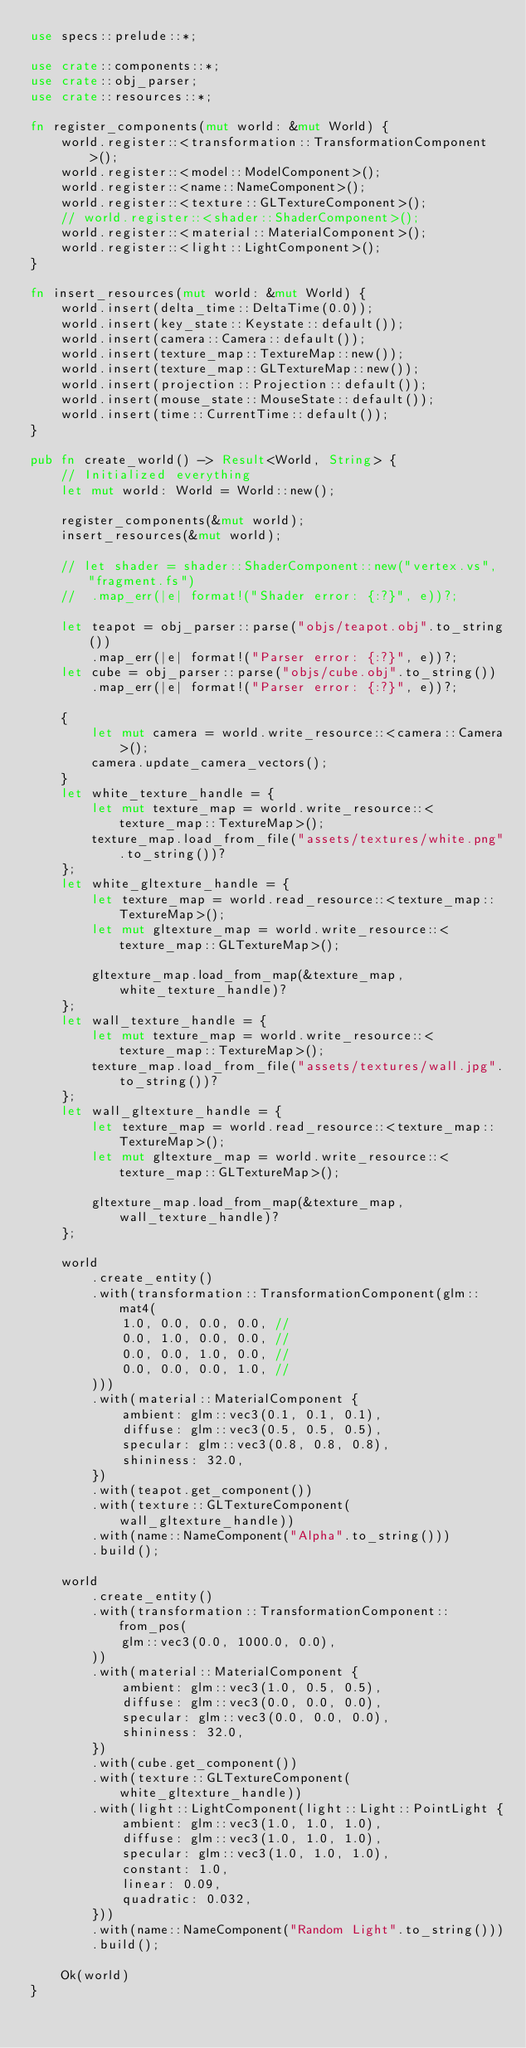<code> <loc_0><loc_0><loc_500><loc_500><_Rust_>use specs::prelude::*;

use crate::components::*;
use crate::obj_parser;
use crate::resources::*;

fn register_components(mut world: &mut World) {
	world.register::<transformation::TransformationComponent>();
	world.register::<model::ModelComponent>();
	world.register::<name::NameComponent>();
	world.register::<texture::GLTextureComponent>();
	// world.register::<shader::ShaderComponent>();
	world.register::<material::MaterialComponent>();
	world.register::<light::LightComponent>();
}

fn insert_resources(mut world: &mut World) {
	world.insert(delta_time::DeltaTime(0.0));
	world.insert(key_state::Keystate::default());
	world.insert(camera::Camera::default());
	world.insert(texture_map::TextureMap::new());
	world.insert(texture_map::GLTextureMap::new());
	world.insert(projection::Projection::default());
	world.insert(mouse_state::MouseState::default());
	world.insert(time::CurrentTime::default());
}

pub fn create_world() -> Result<World, String> {
	// Initialized everything
	let mut world: World = World::new();

	register_components(&mut world);
	insert_resources(&mut world);

	// let shader = shader::ShaderComponent::new("vertex.vs", "fragment.fs")
	// 	.map_err(|e| format!("Shader error: {:?}", e))?;

	let teapot = obj_parser::parse("objs/teapot.obj".to_string())
		.map_err(|e| format!("Parser error: {:?}", e))?;
	let cube = obj_parser::parse("objs/cube.obj".to_string())
		.map_err(|e| format!("Parser error: {:?}", e))?;

	{
		let mut camera = world.write_resource::<camera::Camera>();
		camera.update_camera_vectors();
	}
	let white_texture_handle = {
		let mut texture_map = world.write_resource::<texture_map::TextureMap>();
		texture_map.load_from_file("assets/textures/white.png".to_string())?
	};
	let white_gltexture_handle = {
		let texture_map = world.read_resource::<texture_map::TextureMap>();
		let mut gltexture_map = world.write_resource::<texture_map::GLTextureMap>();

		gltexture_map.load_from_map(&texture_map, white_texture_handle)?
	};
	let wall_texture_handle = {
		let mut texture_map = world.write_resource::<texture_map::TextureMap>();
		texture_map.load_from_file("assets/textures/wall.jpg".to_string())?
	};
	let wall_gltexture_handle = {
		let texture_map = world.read_resource::<texture_map::TextureMap>();
		let mut gltexture_map = world.write_resource::<texture_map::GLTextureMap>();

		gltexture_map.load_from_map(&texture_map, wall_texture_handle)?
	};

	world
		.create_entity()
		.with(transformation::TransformationComponent(glm::mat4(
			1.0, 0.0, 0.0, 0.0, //
			0.0, 1.0, 0.0, 0.0, //
			0.0, 0.0, 1.0, 0.0, //
			0.0, 0.0, 0.0, 1.0, //
		)))
		.with(material::MaterialComponent {
			ambient: glm::vec3(0.1, 0.1, 0.1),
			diffuse: glm::vec3(0.5, 0.5, 0.5),
			specular: glm::vec3(0.8, 0.8, 0.8),
			shininess: 32.0,
		})
		.with(teapot.get_component())
		.with(texture::GLTextureComponent(wall_gltexture_handle))
		.with(name::NameComponent("Alpha".to_string()))
		.build();

	world
		.create_entity()
		.with(transformation::TransformationComponent::from_pos(
			glm::vec3(0.0, 1000.0, 0.0),
		))
		.with(material::MaterialComponent {
			ambient: glm::vec3(1.0, 0.5, 0.5),
			diffuse: glm::vec3(0.0, 0.0, 0.0),
			specular: glm::vec3(0.0, 0.0, 0.0),
			shininess: 32.0,
		})
		.with(cube.get_component())
		.with(texture::GLTextureComponent(white_gltexture_handle))
		.with(light::LightComponent(light::Light::PointLight {
			ambient: glm::vec3(1.0, 1.0, 1.0),
			diffuse: glm::vec3(1.0, 1.0, 1.0),
			specular: glm::vec3(1.0, 1.0, 1.0),
			constant: 1.0,
			linear: 0.09,
			quadratic: 0.032,
		}))
		.with(name::NameComponent("Random Light".to_string()))
		.build();

	Ok(world)
}
</code> 